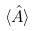<formula> <loc_0><loc_0><loc_500><loc_500>\langle { \hat { A } } \rangle</formula> 